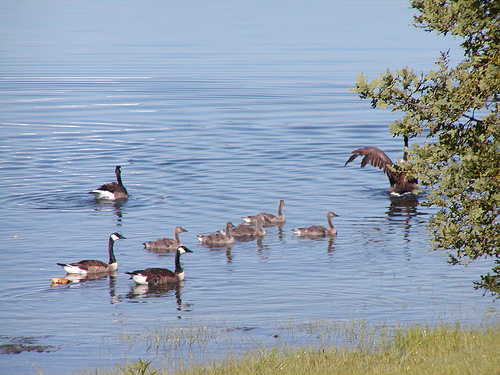<image>
Can you confirm if the bird is above the water? No. The bird is not positioned above the water. The vertical arrangement shows a different relationship. 